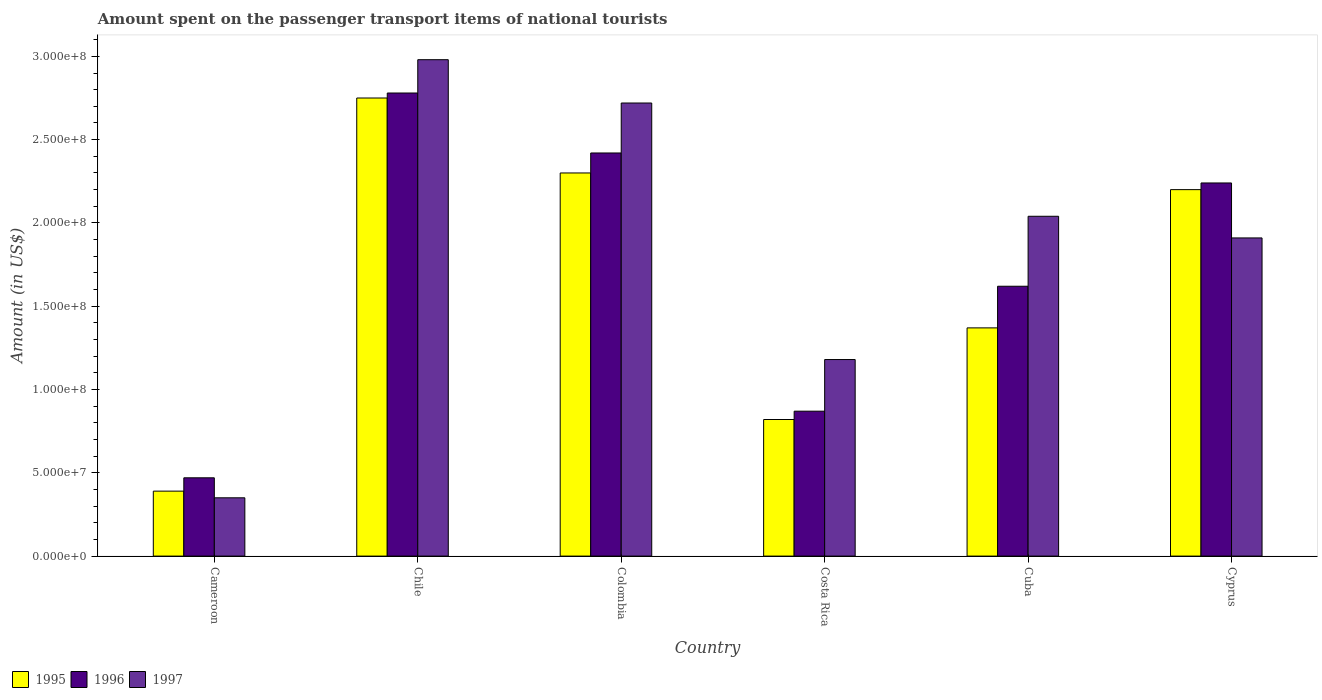Are the number of bars on each tick of the X-axis equal?
Make the answer very short. Yes. How many bars are there on the 2nd tick from the left?
Offer a very short reply. 3. What is the label of the 1st group of bars from the left?
Your answer should be compact. Cameroon. In how many cases, is the number of bars for a given country not equal to the number of legend labels?
Your response must be concise. 0. What is the amount spent on the passenger transport items of national tourists in 1997 in Colombia?
Your answer should be very brief. 2.72e+08. Across all countries, what is the maximum amount spent on the passenger transport items of national tourists in 1995?
Keep it short and to the point. 2.75e+08. Across all countries, what is the minimum amount spent on the passenger transport items of national tourists in 1995?
Offer a terse response. 3.90e+07. In which country was the amount spent on the passenger transport items of national tourists in 1997 minimum?
Give a very brief answer. Cameroon. What is the total amount spent on the passenger transport items of national tourists in 1996 in the graph?
Offer a terse response. 1.04e+09. What is the difference between the amount spent on the passenger transport items of national tourists in 1996 in Colombia and that in Costa Rica?
Keep it short and to the point. 1.55e+08. What is the difference between the amount spent on the passenger transport items of national tourists in 1997 in Cyprus and the amount spent on the passenger transport items of national tourists in 1996 in Costa Rica?
Your response must be concise. 1.04e+08. What is the average amount spent on the passenger transport items of national tourists in 1996 per country?
Give a very brief answer. 1.73e+08. What is the difference between the amount spent on the passenger transport items of national tourists of/in 1997 and amount spent on the passenger transport items of national tourists of/in 1995 in Cyprus?
Offer a terse response. -2.90e+07. In how many countries, is the amount spent on the passenger transport items of national tourists in 1995 greater than 130000000 US$?
Give a very brief answer. 4. What is the ratio of the amount spent on the passenger transport items of national tourists in 1996 in Cameroon to that in Cuba?
Your response must be concise. 0.29. Is the difference between the amount spent on the passenger transport items of national tourists in 1997 in Cuba and Cyprus greater than the difference between the amount spent on the passenger transport items of national tourists in 1995 in Cuba and Cyprus?
Your response must be concise. Yes. What is the difference between the highest and the second highest amount spent on the passenger transport items of national tourists in 1997?
Give a very brief answer. 2.60e+07. What is the difference between the highest and the lowest amount spent on the passenger transport items of national tourists in 1995?
Provide a succinct answer. 2.36e+08. Is the sum of the amount spent on the passenger transport items of national tourists in 1996 in Chile and Cyprus greater than the maximum amount spent on the passenger transport items of national tourists in 1997 across all countries?
Keep it short and to the point. Yes. What does the 3rd bar from the left in Costa Rica represents?
Provide a short and direct response. 1997. What does the 1st bar from the right in Cameroon represents?
Ensure brevity in your answer.  1997. Are all the bars in the graph horizontal?
Offer a very short reply. No. How many countries are there in the graph?
Give a very brief answer. 6. What is the difference between two consecutive major ticks on the Y-axis?
Provide a short and direct response. 5.00e+07. Does the graph contain any zero values?
Your response must be concise. No. Does the graph contain grids?
Give a very brief answer. No. Where does the legend appear in the graph?
Give a very brief answer. Bottom left. How many legend labels are there?
Offer a terse response. 3. What is the title of the graph?
Offer a very short reply. Amount spent on the passenger transport items of national tourists. Does "2003" appear as one of the legend labels in the graph?
Provide a short and direct response. No. What is the label or title of the X-axis?
Make the answer very short. Country. What is the label or title of the Y-axis?
Your response must be concise. Amount (in US$). What is the Amount (in US$) of 1995 in Cameroon?
Offer a terse response. 3.90e+07. What is the Amount (in US$) of 1996 in Cameroon?
Your answer should be very brief. 4.70e+07. What is the Amount (in US$) of 1997 in Cameroon?
Provide a short and direct response. 3.50e+07. What is the Amount (in US$) of 1995 in Chile?
Your answer should be compact. 2.75e+08. What is the Amount (in US$) of 1996 in Chile?
Ensure brevity in your answer.  2.78e+08. What is the Amount (in US$) in 1997 in Chile?
Your response must be concise. 2.98e+08. What is the Amount (in US$) of 1995 in Colombia?
Offer a very short reply. 2.30e+08. What is the Amount (in US$) of 1996 in Colombia?
Offer a very short reply. 2.42e+08. What is the Amount (in US$) in 1997 in Colombia?
Provide a short and direct response. 2.72e+08. What is the Amount (in US$) of 1995 in Costa Rica?
Give a very brief answer. 8.20e+07. What is the Amount (in US$) of 1996 in Costa Rica?
Ensure brevity in your answer.  8.70e+07. What is the Amount (in US$) in 1997 in Costa Rica?
Provide a succinct answer. 1.18e+08. What is the Amount (in US$) in 1995 in Cuba?
Your answer should be very brief. 1.37e+08. What is the Amount (in US$) of 1996 in Cuba?
Offer a very short reply. 1.62e+08. What is the Amount (in US$) in 1997 in Cuba?
Offer a very short reply. 2.04e+08. What is the Amount (in US$) of 1995 in Cyprus?
Offer a terse response. 2.20e+08. What is the Amount (in US$) of 1996 in Cyprus?
Ensure brevity in your answer.  2.24e+08. What is the Amount (in US$) in 1997 in Cyprus?
Ensure brevity in your answer.  1.91e+08. Across all countries, what is the maximum Amount (in US$) in 1995?
Provide a succinct answer. 2.75e+08. Across all countries, what is the maximum Amount (in US$) of 1996?
Ensure brevity in your answer.  2.78e+08. Across all countries, what is the maximum Amount (in US$) of 1997?
Ensure brevity in your answer.  2.98e+08. Across all countries, what is the minimum Amount (in US$) in 1995?
Your answer should be very brief. 3.90e+07. Across all countries, what is the minimum Amount (in US$) of 1996?
Give a very brief answer. 4.70e+07. Across all countries, what is the minimum Amount (in US$) in 1997?
Provide a succinct answer. 3.50e+07. What is the total Amount (in US$) of 1995 in the graph?
Ensure brevity in your answer.  9.83e+08. What is the total Amount (in US$) of 1996 in the graph?
Provide a succinct answer. 1.04e+09. What is the total Amount (in US$) of 1997 in the graph?
Your response must be concise. 1.12e+09. What is the difference between the Amount (in US$) in 1995 in Cameroon and that in Chile?
Offer a very short reply. -2.36e+08. What is the difference between the Amount (in US$) of 1996 in Cameroon and that in Chile?
Provide a short and direct response. -2.31e+08. What is the difference between the Amount (in US$) in 1997 in Cameroon and that in Chile?
Offer a very short reply. -2.63e+08. What is the difference between the Amount (in US$) of 1995 in Cameroon and that in Colombia?
Provide a short and direct response. -1.91e+08. What is the difference between the Amount (in US$) in 1996 in Cameroon and that in Colombia?
Your response must be concise. -1.95e+08. What is the difference between the Amount (in US$) of 1997 in Cameroon and that in Colombia?
Provide a succinct answer. -2.37e+08. What is the difference between the Amount (in US$) in 1995 in Cameroon and that in Costa Rica?
Offer a terse response. -4.30e+07. What is the difference between the Amount (in US$) in 1996 in Cameroon and that in Costa Rica?
Your answer should be very brief. -4.00e+07. What is the difference between the Amount (in US$) in 1997 in Cameroon and that in Costa Rica?
Give a very brief answer. -8.30e+07. What is the difference between the Amount (in US$) in 1995 in Cameroon and that in Cuba?
Provide a succinct answer. -9.80e+07. What is the difference between the Amount (in US$) of 1996 in Cameroon and that in Cuba?
Provide a short and direct response. -1.15e+08. What is the difference between the Amount (in US$) of 1997 in Cameroon and that in Cuba?
Provide a succinct answer. -1.69e+08. What is the difference between the Amount (in US$) of 1995 in Cameroon and that in Cyprus?
Make the answer very short. -1.81e+08. What is the difference between the Amount (in US$) in 1996 in Cameroon and that in Cyprus?
Your answer should be very brief. -1.77e+08. What is the difference between the Amount (in US$) in 1997 in Cameroon and that in Cyprus?
Offer a terse response. -1.56e+08. What is the difference between the Amount (in US$) of 1995 in Chile and that in Colombia?
Your answer should be very brief. 4.50e+07. What is the difference between the Amount (in US$) in 1996 in Chile and that in Colombia?
Make the answer very short. 3.60e+07. What is the difference between the Amount (in US$) of 1997 in Chile and that in Colombia?
Make the answer very short. 2.60e+07. What is the difference between the Amount (in US$) in 1995 in Chile and that in Costa Rica?
Make the answer very short. 1.93e+08. What is the difference between the Amount (in US$) in 1996 in Chile and that in Costa Rica?
Offer a very short reply. 1.91e+08. What is the difference between the Amount (in US$) in 1997 in Chile and that in Costa Rica?
Ensure brevity in your answer.  1.80e+08. What is the difference between the Amount (in US$) of 1995 in Chile and that in Cuba?
Keep it short and to the point. 1.38e+08. What is the difference between the Amount (in US$) of 1996 in Chile and that in Cuba?
Provide a short and direct response. 1.16e+08. What is the difference between the Amount (in US$) in 1997 in Chile and that in Cuba?
Provide a succinct answer. 9.40e+07. What is the difference between the Amount (in US$) of 1995 in Chile and that in Cyprus?
Your answer should be very brief. 5.50e+07. What is the difference between the Amount (in US$) in 1996 in Chile and that in Cyprus?
Your answer should be compact. 5.40e+07. What is the difference between the Amount (in US$) of 1997 in Chile and that in Cyprus?
Give a very brief answer. 1.07e+08. What is the difference between the Amount (in US$) in 1995 in Colombia and that in Costa Rica?
Provide a succinct answer. 1.48e+08. What is the difference between the Amount (in US$) in 1996 in Colombia and that in Costa Rica?
Make the answer very short. 1.55e+08. What is the difference between the Amount (in US$) of 1997 in Colombia and that in Costa Rica?
Your answer should be very brief. 1.54e+08. What is the difference between the Amount (in US$) in 1995 in Colombia and that in Cuba?
Provide a succinct answer. 9.30e+07. What is the difference between the Amount (in US$) in 1996 in Colombia and that in Cuba?
Your answer should be compact. 8.00e+07. What is the difference between the Amount (in US$) of 1997 in Colombia and that in Cuba?
Provide a short and direct response. 6.80e+07. What is the difference between the Amount (in US$) of 1995 in Colombia and that in Cyprus?
Provide a short and direct response. 1.00e+07. What is the difference between the Amount (in US$) in 1996 in Colombia and that in Cyprus?
Your answer should be compact. 1.80e+07. What is the difference between the Amount (in US$) in 1997 in Colombia and that in Cyprus?
Offer a terse response. 8.10e+07. What is the difference between the Amount (in US$) of 1995 in Costa Rica and that in Cuba?
Offer a terse response. -5.50e+07. What is the difference between the Amount (in US$) of 1996 in Costa Rica and that in Cuba?
Offer a very short reply. -7.50e+07. What is the difference between the Amount (in US$) of 1997 in Costa Rica and that in Cuba?
Offer a very short reply. -8.60e+07. What is the difference between the Amount (in US$) in 1995 in Costa Rica and that in Cyprus?
Offer a terse response. -1.38e+08. What is the difference between the Amount (in US$) in 1996 in Costa Rica and that in Cyprus?
Your answer should be very brief. -1.37e+08. What is the difference between the Amount (in US$) in 1997 in Costa Rica and that in Cyprus?
Make the answer very short. -7.30e+07. What is the difference between the Amount (in US$) in 1995 in Cuba and that in Cyprus?
Provide a succinct answer. -8.30e+07. What is the difference between the Amount (in US$) of 1996 in Cuba and that in Cyprus?
Make the answer very short. -6.20e+07. What is the difference between the Amount (in US$) of 1997 in Cuba and that in Cyprus?
Your response must be concise. 1.30e+07. What is the difference between the Amount (in US$) of 1995 in Cameroon and the Amount (in US$) of 1996 in Chile?
Your response must be concise. -2.39e+08. What is the difference between the Amount (in US$) in 1995 in Cameroon and the Amount (in US$) in 1997 in Chile?
Provide a short and direct response. -2.59e+08. What is the difference between the Amount (in US$) of 1996 in Cameroon and the Amount (in US$) of 1997 in Chile?
Offer a very short reply. -2.51e+08. What is the difference between the Amount (in US$) of 1995 in Cameroon and the Amount (in US$) of 1996 in Colombia?
Your response must be concise. -2.03e+08. What is the difference between the Amount (in US$) in 1995 in Cameroon and the Amount (in US$) in 1997 in Colombia?
Provide a short and direct response. -2.33e+08. What is the difference between the Amount (in US$) in 1996 in Cameroon and the Amount (in US$) in 1997 in Colombia?
Ensure brevity in your answer.  -2.25e+08. What is the difference between the Amount (in US$) in 1995 in Cameroon and the Amount (in US$) in 1996 in Costa Rica?
Provide a succinct answer. -4.80e+07. What is the difference between the Amount (in US$) of 1995 in Cameroon and the Amount (in US$) of 1997 in Costa Rica?
Your answer should be very brief. -7.90e+07. What is the difference between the Amount (in US$) of 1996 in Cameroon and the Amount (in US$) of 1997 in Costa Rica?
Your answer should be compact. -7.10e+07. What is the difference between the Amount (in US$) of 1995 in Cameroon and the Amount (in US$) of 1996 in Cuba?
Offer a terse response. -1.23e+08. What is the difference between the Amount (in US$) in 1995 in Cameroon and the Amount (in US$) in 1997 in Cuba?
Offer a very short reply. -1.65e+08. What is the difference between the Amount (in US$) in 1996 in Cameroon and the Amount (in US$) in 1997 in Cuba?
Your response must be concise. -1.57e+08. What is the difference between the Amount (in US$) in 1995 in Cameroon and the Amount (in US$) in 1996 in Cyprus?
Your answer should be very brief. -1.85e+08. What is the difference between the Amount (in US$) of 1995 in Cameroon and the Amount (in US$) of 1997 in Cyprus?
Give a very brief answer. -1.52e+08. What is the difference between the Amount (in US$) of 1996 in Cameroon and the Amount (in US$) of 1997 in Cyprus?
Offer a very short reply. -1.44e+08. What is the difference between the Amount (in US$) of 1995 in Chile and the Amount (in US$) of 1996 in Colombia?
Your response must be concise. 3.30e+07. What is the difference between the Amount (in US$) of 1995 in Chile and the Amount (in US$) of 1997 in Colombia?
Provide a short and direct response. 3.00e+06. What is the difference between the Amount (in US$) of 1995 in Chile and the Amount (in US$) of 1996 in Costa Rica?
Offer a terse response. 1.88e+08. What is the difference between the Amount (in US$) in 1995 in Chile and the Amount (in US$) in 1997 in Costa Rica?
Your response must be concise. 1.57e+08. What is the difference between the Amount (in US$) of 1996 in Chile and the Amount (in US$) of 1997 in Costa Rica?
Make the answer very short. 1.60e+08. What is the difference between the Amount (in US$) in 1995 in Chile and the Amount (in US$) in 1996 in Cuba?
Provide a succinct answer. 1.13e+08. What is the difference between the Amount (in US$) in 1995 in Chile and the Amount (in US$) in 1997 in Cuba?
Offer a very short reply. 7.10e+07. What is the difference between the Amount (in US$) in 1996 in Chile and the Amount (in US$) in 1997 in Cuba?
Provide a short and direct response. 7.40e+07. What is the difference between the Amount (in US$) in 1995 in Chile and the Amount (in US$) in 1996 in Cyprus?
Your response must be concise. 5.10e+07. What is the difference between the Amount (in US$) of 1995 in Chile and the Amount (in US$) of 1997 in Cyprus?
Your answer should be compact. 8.40e+07. What is the difference between the Amount (in US$) in 1996 in Chile and the Amount (in US$) in 1997 in Cyprus?
Your response must be concise. 8.70e+07. What is the difference between the Amount (in US$) in 1995 in Colombia and the Amount (in US$) in 1996 in Costa Rica?
Provide a succinct answer. 1.43e+08. What is the difference between the Amount (in US$) in 1995 in Colombia and the Amount (in US$) in 1997 in Costa Rica?
Give a very brief answer. 1.12e+08. What is the difference between the Amount (in US$) in 1996 in Colombia and the Amount (in US$) in 1997 in Costa Rica?
Ensure brevity in your answer.  1.24e+08. What is the difference between the Amount (in US$) of 1995 in Colombia and the Amount (in US$) of 1996 in Cuba?
Offer a very short reply. 6.80e+07. What is the difference between the Amount (in US$) in 1995 in Colombia and the Amount (in US$) in 1997 in Cuba?
Provide a short and direct response. 2.60e+07. What is the difference between the Amount (in US$) of 1996 in Colombia and the Amount (in US$) of 1997 in Cuba?
Provide a succinct answer. 3.80e+07. What is the difference between the Amount (in US$) in 1995 in Colombia and the Amount (in US$) in 1996 in Cyprus?
Make the answer very short. 6.00e+06. What is the difference between the Amount (in US$) in 1995 in Colombia and the Amount (in US$) in 1997 in Cyprus?
Offer a very short reply. 3.90e+07. What is the difference between the Amount (in US$) in 1996 in Colombia and the Amount (in US$) in 1997 in Cyprus?
Provide a succinct answer. 5.10e+07. What is the difference between the Amount (in US$) in 1995 in Costa Rica and the Amount (in US$) in 1996 in Cuba?
Make the answer very short. -8.00e+07. What is the difference between the Amount (in US$) of 1995 in Costa Rica and the Amount (in US$) of 1997 in Cuba?
Your response must be concise. -1.22e+08. What is the difference between the Amount (in US$) in 1996 in Costa Rica and the Amount (in US$) in 1997 in Cuba?
Offer a very short reply. -1.17e+08. What is the difference between the Amount (in US$) in 1995 in Costa Rica and the Amount (in US$) in 1996 in Cyprus?
Offer a terse response. -1.42e+08. What is the difference between the Amount (in US$) in 1995 in Costa Rica and the Amount (in US$) in 1997 in Cyprus?
Give a very brief answer. -1.09e+08. What is the difference between the Amount (in US$) of 1996 in Costa Rica and the Amount (in US$) of 1997 in Cyprus?
Provide a succinct answer. -1.04e+08. What is the difference between the Amount (in US$) in 1995 in Cuba and the Amount (in US$) in 1996 in Cyprus?
Give a very brief answer. -8.70e+07. What is the difference between the Amount (in US$) in 1995 in Cuba and the Amount (in US$) in 1997 in Cyprus?
Keep it short and to the point. -5.40e+07. What is the difference between the Amount (in US$) of 1996 in Cuba and the Amount (in US$) of 1997 in Cyprus?
Your answer should be very brief. -2.90e+07. What is the average Amount (in US$) in 1995 per country?
Your answer should be compact. 1.64e+08. What is the average Amount (in US$) of 1996 per country?
Offer a very short reply. 1.73e+08. What is the average Amount (in US$) of 1997 per country?
Your answer should be compact. 1.86e+08. What is the difference between the Amount (in US$) of 1995 and Amount (in US$) of 1996 in Cameroon?
Your answer should be very brief. -8.00e+06. What is the difference between the Amount (in US$) in 1995 and Amount (in US$) in 1997 in Cameroon?
Give a very brief answer. 4.00e+06. What is the difference between the Amount (in US$) in 1995 and Amount (in US$) in 1996 in Chile?
Your answer should be compact. -3.00e+06. What is the difference between the Amount (in US$) in 1995 and Amount (in US$) in 1997 in Chile?
Offer a terse response. -2.30e+07. What is the difference between the Amount (in US$) in 1996 and Amount (in US$) in 1997 in Chile?
Keep it short and to the point. -2.00e+07. What is the difference between the Amount (in US$) in 1995 and Amount (in US$) in 1996 in Colombia?
Provide a short and direct response. -1.20e+07. What is the difference between the Amount (in US$) of 1995 and Amount (in US$) of 1997 in Colombia?
Make the answer very short. -4.20e+07. What is the difference between the Amount (in US$) in 1996 and Amount (in US$) in 1997 in Colombia?
Keep it short and to the point. -3.00e+07. What is the difference between the Amount (in US$) in 1995 and Amount (in US$) in 1996 in Costa Rica?
Provide a short and direct response. -5.00e+06. What is the difference between the Amount (in US$) in 1995 and Amount (in US$) in 1997 in Costa Rica?
Make the answer very short. -3.60e+07. What is the difference between the Amount (in US$) of 1996 and Amount (in US$) of 1997 in Costa Rica?
Provide a short and direct response. -3.10e+07. What is the difference between the Amount (in US$) of 1995 and Amount (in US$) of 1996 in Cuba?
Your answer should be compact. -2.50e+07. What is the difference between the Amount (in US$) in 1995 and Amount (in US$) in 1997 in Cuba?
Make the answer very short. -6.70e+07. What is the difference between the Amount (in US$) in 1996 and Amount (in US$) in 1997 in Cuba?
Your response must be concise. -4.20e+07. What is the difference between the Amount (in US$) in 1995 and Amount (in US$) in 1996 in Cyprus?
Give a very brief answer. -4.00e+06. What is the difference between the Amount (in US$) in 1995 and Amount (in US$) in 1997 in Cyprus?
Your answer should be very brief. 2.90e+07. What is the difference between the Amount (in US$) of 1996 and Amount (in US$) of 1997 in Cyprus?
Offer a very short reply. 3.30e+07. What is the ratio of the Amount (in US$) in 1995 in Cameroon to that in Chile?
Your response must be concise. 0.14. What is the ratio of the Amount (in US$) of 1996 in Cameroon to that in Chile?
Provide a succinct answer. 0.17. What is the ratio of the Amount (in US$) of 1997 in Cameroon to that in Chile?
Keep it short and to the point. 0.12. What is the ratio of the Amount (in US$) in 1995 in Cameroon to that in Colombia?
Give a very brief answer. 0.17. What is the ratio of the Amount (in US$) in 1996 in Cameroon to that in Colombia?
Your answer should be very brief. 0.19. What is the ratio of the Amount (in US$) in 1997 in Cameroon to that in Colombia?
Give a very brief answer. 0.13. What is the ratio of the Amount (in US$) in 1995 in Cameroon to that in Costa Rica?
Offer a terse response. 0.48. What is the ratio of the Amount (in US$) of 1996 in Cameroon to that in Costa Rica?
Ensure brevity in your answer.  0.54. What is the ratio of the Amount (in US$) of 1997 in Cameroon to that in Costa Rica?
Provide a succinct answer. 0.3. What is the ratio of the Amount (in US$) of 1995 in Cameroon to that in Cuba?
Ensure brevity in your answer.  0.28. What is the ratio of the Amount (in US$) of 1996 in Cameroon to that in Cuba?
Offer a very short reply. 0.29. What is the ratio of the Amount (in US$) in 1997 in Cameroon to that in Cuba?
Offer a very short reply. 0.17. What is the ratio of the Amount (in US$) of 1995 in Cameroon to that in Cyprus?
Provide a succinct answer. 0.18. What is the ratio of the Amount (in US$) in 1996 in Cameroon to that in Cyprus?
Provide a short and direct response. 0.21. What is the ratio of the Amount (in US$) of 1997 in Cameroon to that in Cyprus?
Your answer should be very brief. 0.18. What is the ratio of the Amount (in US$) in 1995 in Chile to that in Colombia?
Provide a succinct answer. 1.2. What is the ratio of the Amount (in US$) in 1996 in Chile to that in Colombia?
Offer a very short reply. 1.15. What is the ratio of the Amount (in US$) in 1997 in Chile to that in Colombia?
Your answer should be compact. 1.1. What is the ratio of the Amount (in US$) in 1995 in Chile to that in Costa Rica?
Your response must be concise. 3.35. What is the ratio of the Amount (in US$) of 1996 in Chile to that in Costa Rica?
Provide a succinct answer. 3.2. What is the ratio of the Amount (in US$) in 1997 in Chile to that in Costa Rica?
Offer a terse response. 2.53. What is the ratio of the Amount (in US$) in 1995 in Chile to that in Cuba?
Make the answer very short. 2.01. What is the ratio of the Amount (in US$) in 1996 in Chile to that in Cuba?
Your response must be concise. 1.72. What is the ratio of the Amount (in US$) in 1997 in Chile to that in Cuba?
Your answer should be very brief. 1.46. What is the ratio of the Amount (in US$) in 1995 in Chile to that in Cyprus?
Your answer should be compact. 1.25. What is the ratio of the Amount (in US$) in 1996 in Chile to that in Cyprus?
Your response must be concise. 1.24. What is the ratio of the Amount (in US$) of 1997 in Chile to that in Cyprus?
Provide a succinct answer. 1.56. What is the ratio of the Amount (in US$) in 1995 in Colombia to that in Costa Rica?
Your answer should be compact. 2.8. What is the ratio of the Amount (in US$) of 1996 in Colombia to that in Costa Rica?
Offer a terse response. 2.78. What is the ratio of the Amount (in US$) in 1997 in Colombia to that in Costa Rica?
Offer a very short reply. 2.31. What is the ratio of the Amount (in US$) of 1995 in Colombia to that in Cuba?
Provide a short and direct response. 1.68. What is the ratio of the Amount (in US$) in 1996 in Colombia to that in Cuba?
Make the answer very short. 1.49. What is the ratio of the Amount (in US$) in 1997 in Colombia to that in Cuba?
Provide a succinct answer. 1.33. What is the ratio of the Amount (in US$) in 1995 in Colombia to that in Cyprus?
Offer a terse response. 1.05. What is the ratio of the Amount (in US$) in 1996 in Colombia to that in Cyprus?
Your answer should be compact. 1.08. What is the ratio of the Amount (in US$) in 1997 in Colombia to that in Cyprus?
Offer a very short reply. 1.42. What is the ratio of the Amount (in US$) in 1995 in Costa Rica to that in Cuba?
Ensure brevity in your answer.  0.6. What is the ratio of the Amount (in US$) in 1996 in Costa Rica to that in Cuba?
Provide a short and direct response. 0.54. What is the ratio of the Amount (in US$) of 1997 in Costa Rica to that in Cuba?
Keep it short and to the point. 0.58. What is the ratio of the Amount (in US$) of 1995 in Costa Rica to that in Cyprus?
Provide a succinct answer. 0.37. What is the ratio of the Amount (in US$) in 1996 in Costa Rica to that in Cyprus?
Offer a terse response. 0.39. What is the ratio of the Amount (in US$) in 1997 in Costa Rica to that in Cyprus?
Provide a succinct answer. 0.62. What is the ratio of the Amount (in US$) of 1995 in Cuba to that in Cyprus?
Offer a terse response. 0.62. What is the ratio of the Amount (in US$) in 1996 in Cuba to that in Cyprus?
Give a very brief answer. 0.72. What is the ratio of the Amount (in US$) in 1997 in Cuba to that in Cyprus?
Give a very brief answer. 1.07. What is the difference between the highest and the second highest Amount (in US$) of 1995?
Offer a terse response. 4.50e+07. What is the difference between the highest and the second highest Amount (in US$) in 1996?
Your response must be concise. 3.60e+07. What is the difference between the highest and the second highest Amount (in US$) of 1997?
Keep it short and to the point. 2.60e+07. What is the difference between the highest and the lowest Amount (in US$) of 1995?
Your answer should be very brief. 2.36e+08. What is the difference between the highest and the lowest Amount (in US$) in 1996?
Give a very brief answer. 2.31e+08. What is the difference between the highest and the lowest Amount (in US$) of 1997?
Your response must be concise. 2.63e+08. 